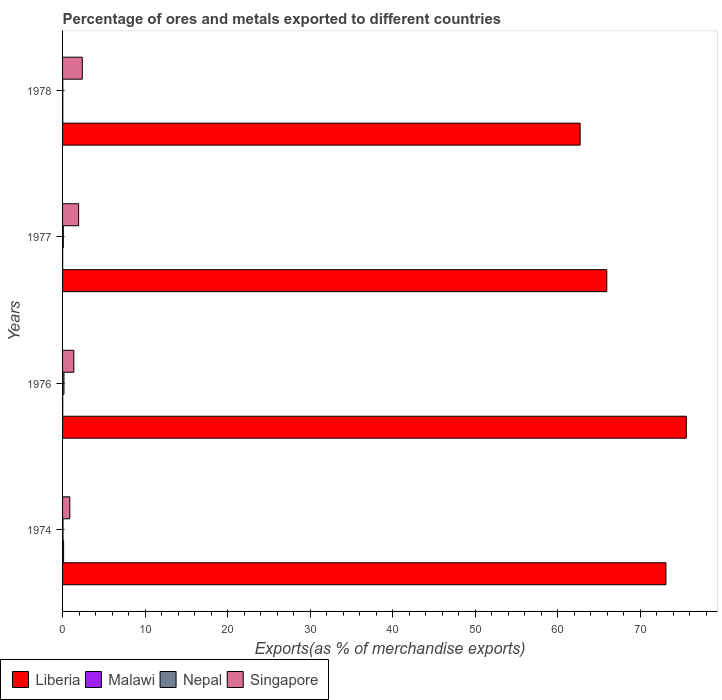How many different coloured bars are there?
Your response must be concise. 4. How many groups of bars are there?
Give a very brief answer. 4. How many bars are there on the 2nd tick from the top?
Make the answer very short. 4. How many bars are there on the 4th tick from the bottom?
Ensure brevity in your answer.  4. What is the label of the 1st group of bars from the top?
Ensure brevity in your answer.  1978. In how many cases, is the number of bars for a given year not equal to the number of legend labels?
Your answer should be very brief. 0. What is the percentage of exports to different countries in Liberia in 1978?
Your answer should be very brief. 62.74. Across all years, what is the maximum percentage of exports to different countries in Malawi?
Make the answer very short. 0.13. Across all years, what is the minimum percentage of exports to different countries in Malawi?
Make the answer very short. 0.01. In which year was the percentage of exports to different countries in Singapore maximum?
Provide a succinct answer. 1978. In which year was the percentage of exports to different countries in Singapore minimum?
Your answer should be compact. 1974. What is the total percentage of exports to different countries in Malawi in the graph?
Ensure brevity in your answer.  0.19. What is the difference between the percentage of exports to different countries in Liberia in 1976 and that in 1978?
Your answer should be compact. 12.87. What is the difference between the percentage of exports to different countries in Nepal in 1976 and the percentage of exports to different countries in Malawi in 1974?
Offer a terse response. 0.04. What is the average percentage of exports to different countries in Singapore per year?
Provide a short and direct response. 1.65. In the year 1976, what is the difference between the percentage of exports to different countries in Liberia and percentage of exports to different countries in Malawi?
Ensure brevity in your answer.  75.59. What is the ratio of the percentage of exports to different countries in Nepal in 1974 to that in 1976?
Ensure brevity in your answer.  0.31. Is the percentage of exports to different countries in Singapore in 1976 less than that in 1978?
Your answer should be compact. Yes. What is the difference between the highest and the second highest percentage of exports to different countries in Malawi?
Offer a terse response. 0.1. What is the difference between the highest and the lowest percentage of exports to different countries in Liberia?
Your answer should be compact. 12.87. Is the sum of the percentage of exports to different countries in Malawi in 1976 and 1978 greater than the maximum percentage of exports to different countries in Singapore across all years?
Keep it short and to the point. No. Is it the case that in every year, the sum of the percentage of exports to different countries in Liberia and percentage of exports to different countries in Malawi is greater than the sum of percentage of exports to different countries in Nepal and percentage of exports to different countries in Singapore?
Provide a succinct answer. Yes. What does the 1st bar from the top in 1974 represents?
Give a very brief answer. Singapore. What does the 3rd bar from the bottom in 1977 represents?
Offer a terse response. Nepal. Is it the case that in every year, the sum of the percentage of exports to different countries in Singapore and percentage of exports to different countries in Nepal is greater than the percentage of exports to different countries in Malawi?
Offer a terse response. Yes. How many bars are there?
Keep it short and to the point. 16. Are all the bars in the graph horizontal?
Make the answer very short. Yes. Are the values on the major ticks of X-axis written in scientific E-notation?
Provide a succinct answer. No. Does the graph contain any zero values?
Make the answer very short. No. Does the graph contain grids?
Offer a very short reply. No. Where does the legend appear in the graph?
Ensure brevity in your answer.  Bottom left. What is the title of the graph?
Ensure brevity in your answer.  Percentage of ores and metals exported to different countries. Does "Heavily indebted poor countries" appear as one of the legend labels in the graph?
Provide a succinct answer. No. What is the label or title of the X-axis?
Give a very brief answer. Exports(as % of merchandise exports). What is the Exports(as % of merchandise exports) of Liberia in 1974?
Provide a short and direct response. 73.15. What is the Exports(as % of merchandise exports) in Malawi in 1974?
Your response must be concise. 0.13. What is the Exports(as % of merchandise exports) of Nepal in 1974?
Offer a very short reply. 0.05. What is the Exports(as % of merchandise exports) in Singapore in 1974?
Offer a terse response. 0.88. What is the Exports(as % of merchandise exports) in Liberia in 1976?
Ensure brevity in your answer.  75.61. What is the Exports(as % of merchandise exports) of Malawi in 1976?
Your response must be concise. 0.02. What is the Exports(as % of merchandise exports) in Nepal in 1976?
Give a very brief answer. 0.17. What is the Exports(as % of merchandise exports) of Singapore in 1976?
Make the answer very short. 1.36. What is the Exports(as % of merchandise exports) of Liberia in 1977?
Provide a succinct answer. 65.97. What is the Exports(as % of merchandise exports) of Malawi in 1977?
Your response must be concise. 0.01. What is the Exports(as % of merchandise exports) of Nepal in 1977?
Your answer should be very brief. 0.09. What is the Exports(as % of merchandise exports) of Singapore in 1977?
Provide a short and direct response. 1.95. What is the Exports(as % of merchandise exports) of Liberia in 1978?
Your response must be concise. 62.74. What is the Exports(as % of merchandise exports) in Malawi in 1978?
Provide a short and direct response. 0.03. What is the Exports(as % of merchandise exports) of Nepal in 1978?
Your response must be concise. 0.03. What is the Exports(as % of merchandise exports) of Singapore in 1978?
Your response must be concise. 2.39. Across all years, what is the maximum Exports(as % of merchandise exports) of Liberia?
Keep it short and to the point. 75.61. Across all years, what is the maximum Exports(as % of merchandise exports) in Malawi?
Give a very brief answer. 0.13. Across all years, what is the maximum Exports(as % of merchandise exports) in Nepal?
Make the answer very short. 0.17. Across all years, what is the maximum Exports(as % of merchandise exports) in Singapore?
Your answer should be very brief. 2.39. Across all years, what is the minimum Exports(as % of merchandise exports) in Liberia?
Provide a succinct answer. 62.74. Across all years, what is the minimum Exports(as % of merchandise exports) of Malawi?
Provide a succinct answer. 0.01. Across all years, what is the minimum Exports(as % of merchandise exports) in Nepal?
Your answer should be very brief. 0.03. Across all years, what is the minimum Exports(as % of merchandise exports) of Singapore?
Your answer should be compact. 0.88. What is the total Exports(as % of merchandise exports) in Liberia in the graph?
Offer a terse response. 277.47. What is the total Exports(as % of merchandise exports) of Malawi in the graph?
Your answer should be compact. 0.19. What is the total Exports(as % of merchandise exports) of Nepal in the graph?
Ensure brevity in your answer.  0.34. What is the total Exports(as % of merchandise exports) in Singapore in the graph?
Keep it short and to the point. 6.58. What is the difference between the Exports(as % of merchandise exports) in Liberia in 1974 and that in 1976?
Make the answer very short. -2.47. What is the difference between the Exports(as % of merchandise exports) in Malawi in 1974 and that in 1976?
Give a very brief answer. 0.11. What is the difference between the Exports(as % of merchandise exports) in Nepal in 1974 and that in 1976?
Offer a very short reply. -0.12. What is the difference between the Exports(as % of merchandise exports) in Singapore in 1974 and that in 1976?
Your answer should be compact. -0.49. What is the difference between the Exports(as % of merchandise exports) in Liberia in 1974 and that in 1977?
Your answer should be very brief. 7.17. What is the difference between the Exports(as % of merchandise exports) of Malawi in 1974 and that in 1977?
Your answer should be very brief. 0.11. What is the difference between the Exports(as % of merchandise exports) of Nepal in 1974 and that in 1977?
Provide a succinct answer. -0.04. What is the difference between the Exports(as % of merchandise exports) of Singapore in 1974 and that in 1977?
Your response must be concise. -1.07. What is the difference between the Exports(as % of merchandise exports) of Liberia in 1974 and that in 1978?
Your response must be concise. 10.41. What is the difference between the Exports(as % of merchandise exports) in Malawi in 1974 and that in 1978?
Provide a short and direct response. 0.1. What is the difference between the Exports(as % of merchandise exports) in Nepal in 1974 and that in 1978?
Give a very brief answer. 0.02. What is the difference between the Exports(as % of merchandise exports) of Singapore in 1974 and that in 1978?
Make the answer very short. -1.51. What is the difference between the Exports(as % of merchandise exports) of Liberia in 1976 and that in 1977?
Provide a short and direct response. 9.64. What is the difference between the Exports(as % of merchandise exports) in Malawi in 1976 and that in 1977?
Give a very brief answer. 0.01. What is the difference between the Exports(as % of merchandise exports) of Nepal in 1976 and that in 1977?
Your answer should be very brief. 0.08. What is the difference between the Exports(as % of merchandise exports) in Singapore in 1976 and that in 1977?
Offer a terse response. -0.58. What is the difference between the Exports(as % of merchandise exports) in Liberia in 1976 and that in 1978?
Provide a succinct answer. 12.87. What is the difference between the Exports(as % of merchandise exports) of Malawi in 1976 and that in 1978?
Offer a terse response. -0.01. What is the difference between the Exports(as % of merchandise exports) in Nepal in 1976 and that in 1978?
Your response must be concise. 0.14. What is the difference between the Exports(as % of merchandise exports) in Singapore in 1976 and that in 1978?
Give a very brief answer. -1.03. What is the difference between the Exports(as % of merchandise exports) in Liberia in 1977 and that in 1978?
Make the answer very short. 3.23. What is the difference between the Exports(as % of merchandise exports) of Malawi in 1977 and that in 1978?
Provide a short and direct response. -0.01. What is the difference between the Exports(as % of merchandise exports) in Nepal in 1977 and that in 1978?
Make the answer very short. 0.06. What is the difference between the Exports(as % of merchandise exports) of Singapore in 1977 and that in 1978?
Your answer should be very brief. -0.45. What is the difference between the Exports(as % of merchandise exports) of Liberia in 1974 and the Exports(as % of merchandise exports) of Malawi in 1976?
Keep it short and to the point. 73.13. What is the difference between the Exports(as % of merchandise exports) in Liberia in 1974 and the Exports(as % of merchandise exports) in Nepal in 1976?
Give a very brief answer. 72.98. What is the difference between the Exports(as % of merchandise exports) in Liberia in 1974 and the Exports(as % of merchandise exports) in Singapore in 1976?
Make the answer very short. 71.78. What is the difference between the Exports(as % of merchandise exports) of Malawi in 1974 and the Exports(as % of merchandise exports) of Nepal in 1976?
Keep it short and to the point. -0.04. What is the difference between the Exports(as % of merchandise exports) of Malawi in 1974 and the Exports(as % of merchandise exports) of Singapore in 1976?
Keep it short and to the point. -1.24. What is the difference between the Exports(as % of merchandise exports) in Nepal in 1974 and the Exports(as % of merchandise exports) in Singapore in 1976?
Make the answer very short. -1.31. What is the difference between the Exports(as % of merchandise exports) of Liberia in 1974 and the Exports(as % of merchandise exports) of Malawi in 1977?
Keep it short and to the point. 73.13. What is the difference between the Exports(as % of merchandise exports) of Liberia in 1974 and the Exports(as % of merchandise exports) of Nepal in 1977?
Your answer should be very brief. 73.06. What is the difference between the Exports(as % of merchandise exports) of Liberia in 1974 and the Exports(as % of merchandise exports) of Singapore in 1977?
Provide a succinct answer. 71.2. What is the difference between the Exports(as % of merchandise exports) of Malawi in 1974 and the Exports(as % of merchandise exports) of Nepal in 1977?
Your answer should be very brief. 0.04. What is the difference between the Exports(as % of merchandise exports) in Malawi in 1974 and the Exports(as % of merchandise exports) in Singapore in 1977?
Ensure brevity in your answer.  -1.82. What is the difference between the Exports(as % of merchandise exports) in Nepal in 1974 and the Exports(as % of merchandise exports) in Singapore in 1977?
Give a very brief answer. -1.89. What is the difference between the Exports(as % of merchandise exports) in Liberia in 1974 and the Exports(as % of merchandise exports) in Malawi in 1978?
Give a very brief answer. 73.12. What is the difference between the Exports(as % of merchandise exports) in Liberia in 1974 and the Exports(as % of merchandise exports) in Nepal in 1978?
Give a very brief answer. 73.12. What is the difference between the Exports(as % of merchandise exports) in Liberia in 1974 and the Exports(as % of merchandise exports) in Singapore in 1978?
Offer a very short reply. 70.75. What is the difference between the Exports(as % of merchandise exports) of Malawi in 1974 and the Exports(as % of merchandise exports) of Nepal in 1978?
Keep it short and to the point. 0.1. What is the difference between the Exports(as % of merchandise exports) of Malawi in 1974 and the Exports(as % of merchandise exports) of Singapore in 1978?
Provide a short and direct response. -2.27. What is the difference between the Exports(as % of merchandise exports) of Nepal in 1974 and the Exports(as % of merchandise exports) of Singapore in 1978?
Your answer should be compact. -2.34. What is the difference between the Exports(as % of merchandise exports) in Liberia in 1976 and the Exports(as % of merchandise exports) in Malawi in 1977?
Your answer should be very brief. 75.6. What is the difference between the Exports(as % of merchandise exports) in Liberia in 1976 and the Exports(as % of merchandise exports) in Nepal in 1977?
Offer a terse response. 75.52. What is the difference between the Exports(as % of merchandise exports) in Liberia in 1976 and the Exports(as % of merchandise exports) in Singapore in 1977?
Keep it short and to the point. 73.67. What is the difference between the Exports(as % of merchandise exports) of Malawi in 1976 and the Exports(as % of merchandise exports) of Nepal in 1977?
Your response must be concise. -0.07. What is the difference between the Exports(as % of merchandise exports) of Malawi in 1976 and the Exports(as % of merchandise exports) of Singapore in 1977?
Offer a very short reply. -1.92. What is the difference between the Exports(as % of merchandise exports) in Nepal in 1976 and the Exports(as % of merchandise exports) in Singapore in 1977?
Provide a short and direct response. -1.78. What is the difference between the Exports(as % of merchandise exports) in Liberia in 1976 and the Exports(as % of merchandise exports) in Malawi in 1978?
Provide a succinct answer. 75.58. What is the difference between the Exports(as % of merchandise exports) of Liberia in 1976 and the Exports(as % of merchandise exports) of Nepal in 1978?
Provide a short and direct response. 75.58. What is the difference between the Exports(as % of merchandise exports) in Liberia in 1976 and the Exports(as % of merchandise exports) in Singapore in 1978?
Your answer should be very brief. 73.22. What is the difference between the Exports(as % of merchandise exports) in Malawi in 1976 and the Exports(as % of merchandise exports) in Nepal in 1978?
Your answer should be compact. -0.01. What is the difference between the Exports(as % of merchandise exports) in Malawi in 1976 and the Exports(as % of merchandise exports) in Singapore in 1978?
Keep it short and to the point. -2.37. What is the difference between the Exports(as % of merchandise exports) in Nepal in 1976 and the Exports(as % of merchandise exports) in Singapore in 1978?
Keep it short and to the point. -2.22. What is the difference between the Exports(as % of merchandise exports) in Liberia in 1977 and the Exports(as % of merchandise exports) in Malawi in 1978?
Keep it short and to the point. 65.95. What is the difference between the Exports(as % of merchandise exports) of Liberia in 1977 and the Exports(as % of merchandise exports) of Nepal in 1978?
Your response must be concise. 65.95. What is the difference between the Exports(as % of merchandise exports) in Liberia in 1977 and the Exports(as % of merchandise exports) in Singapore in 1978?
Provide a succinct answer. 63.58. What is the difference between the Exports(as % of merchandise exports) of Malawi in 1977 and the Exports(as % of merchandise exports) of Nepal in 1978?
Provide a succinct answer. -0.02. What is the difference between the Exports(as % of merchandise exports) of Malawi in 1977 and the Exports(as % of merchandise exports) of Singapore in 1978?
Keep it short and to the point. -2.38. What is the difference between the Exports(as % of merchandise exports) of Nepal in 1977 and the Exports(as % of merchandise exports) of Singapore in 1978?
Give a very brief answer. -2.3. What is the average Exports(as % of merchandise exports) of Liberia per year?
Give a very brief answer. 69.37. What is the average Exports(as % of merchandise exports) in Malawi per year?
Offer a very short reply. 0.05. What is the average Exports(as % of merchandise exports) in Nepal per year?
Offer a terse response. 0.08. What is the average Exports(as % of merchandise exports) in Singapore per year?
Offer a terse response. 1.65. In the year 1974, what is the difference between the Exports(as % of merchandise exports) of Liberia and Exports(as % of merchandise exports) of Malawi?
Offer a very short reply. 73.02. In the year 1974, what is the difference between the Exports(as % of merchandise exports) in Liberia and Exports(as % of merchandise exports) in Nepal?
Give a very brief answer. 73.09. In the year 1974, what is the difference between the Exports(as % of merchandise exports) of Liberia and Exports(as % of merchandise exports) of Singapore?
Offer a very short reply. 72.27. In the year 1974, what is the difference between the Exports(as % of merchandise exports) in Malawi and Exports(as % of merchandise exports) in Nepal?
Offer a very short reply. 0.07. In the year 1974, what is the difference between the Exports(as % of merchandise exports) of Malawi and Exports(as % of merchandise exports) of Singapore?
Your answer should be compact. -0.75. In the year 1974, what is the difference between the Exports(as % of merchandise exports) of Nepal and Exports(as % of merchandise exports) of Singapore?
Ensure brevity in your answer.  -0.83. In the year 1976, what is the difference between the Exports(as % of merchandise exports) of Liberia and Exports(as % of merchandise exports) of Malawi?
Make the answer very short. 75.59. In the year 1976, what is the difference between the Exports(as % of merchandise exports) of Liberia and Exports(as % of merchandise exports) of Nepal?
Make the answer very short. 75.44. In the year 1976, what is the difference between the Exports(as % of merchandise exports) in Liberia and Exports(as % of merchandise exports) in Singapore?
Provide a short and direct response. 74.25. In the year 1976, what is the difference between the Exports(as % of merchandise exports) in Malawi and Exports(as % of merchandise exports) in Nepal?
Your response must be concise. -0.15. In the year 1976, what is the difference between the Exports(as % of merchandise exports) of Malawi and Exports(as % of merchandise exports) of Singapore?
Your response must be concise. -1.34. In the year 1976, what is the difference between the Exports(as % of merchandise exports) in Nepal and Exports(as % of merchandise exports) in Singapore?
Keep it short and to the point. -1.2. In the year 1977, what is the difference between the Exports(as % of merchandise exports) in Liberia and Exports(as % of merchandise exports) in Malawi?
Your response must be concise. 65.96. In the year 1977, what is the difference between the Exports(as % of merchandise exports) of Liberia and Exports(as % of merchandise exports) of Nepal?
Provide a short and direct response. 65.88. In the year 1977, what is the difference between the Exports(as % of merchandise exports) in Liberia and Exports(as % of merchandise exports) in Singapore?
Your answer should be compact. 64.03. In the year 1977, what is the difference between the Exports(as % of merchandise exports) in Malawi and Exports(as % of merchandise exports) in Nepal?
Provide a succinct answer. -0.08. In the year 1977, what is the difference between the Exports(as % of merchandise exports) of Malawi and Exports(as % of merchandise exports) of Singapore?
Keep it short and to the point. -1.93. In the year 1977, what is the difference between the Exports(as % of merchandise exports) in Nepal and Exports(as % of merchandise exports) in Singapore?
Give a very brief answer. -1.86. In the year 1978, what is the difference between the Exports(as % of merchandise exports) in Liberia and Exports(as % of merchandise exports) in Malawi?
Your answer should be very brief. 62.71. In the year 1978, what is the difference between the Exports(as % of merchandise exports) of Liberia and Exports(as % of merchandise exports) of Nepal?
Keep it short and to the point. 62.71. In the year 1978, what is the difference between the Exports(as % of merchandise exports) in Liberia and Exports(as % of merchandise exports) in Singapore?
Offer a terse response. 60.35. In the year 1978, what is the difference between the Exports(as % of merchandise exports) of Malawi and Exports(as % of merchandise exports) of Nepal?
Offer a terse response. -0. In the year 1978, what is the difference between the Exports(as % of merchandise exports) in Malawi and Exports(as % of merchandise exports) in Singapore?
Provide a succinct answer. -2.37. In the year 1978, what is the difference between the Exports(as % of merchandise exports) in Nepal and Exports(as % of merchandise exports) in Singapore?
Keep it short and to the point. -2.37. What is the ratio of the Exports(as % of merchandise exports) in Liberia in 1974 to that in 1976?
Your answer should be compact. 0.97. What is the ratio of the Exports(as % of merchandise exports) of Malawi in 1974 to that in 1976?
Provide a succinct answer. 6.03. What is the ratio of the Exports(as % of merchandise exports) of Nepal in 1974 to that in 1976?
Your answer should be compact. 0.31. What is the ratio of the Exports(as % of merchandise exports) in Singapore in 1974 to that in 1976?
Keep it short and to the point. 0.64. What is the ratio of the Exports(as % of merchandise exports) of Liberia in 1974 to that in 1977?
Offer a terse response. 1.11. What is the ratio of the Exports(as % of merchandise exports) of Malawi in 1974 to that in 1977?
Your answer should be very brief. 10.3. What is the ratio of the Exports(as % of merchandise exports) in Nepal in 1974 to that in 1977?
Offer a very short reply. 0.57. What is the ratio of the Exports(as % of merchandise exports) of Singapore in 1974 to that in 1977?
Keep it short and to the point. 0.45. What is the ratio of the Exports(as % of merchandise exports) of Liberia in 1974 to that in 1978?
Your answer should be very brief. 1.17. What is the ratio of the Exports(as % of merchandise exports) in Malawi in 1974 to that in 1978?
Offer a terse response. 4.73. What is the ratio of the Exports(as % of merchandise exports) of Nepal in 1974 to that in 1978?
Provide a succinct answer. 1.88. What is the ratio of the Exports(as % of merchandise exports) of Singapore in 1974 to that in 1978?
Offer a terse response. 0.37. What is the ratio of the Exports(as % of merchandise exports) of Liberia in 1976 to that in 1977?
Give a very brief answer. 1.15. What is the ratio of the Exports(as % of merchandise exports) of Malawi in 1976 to that in 1977?
Provide a succinct answer. 1.71. What is the ratio of the Exports(as % of merchandise exports) in Nepal in 1976 to that in 1977?
Your answer should be compact. 1.86. What is the ratio of the Exports(as % of merchandise exports) of Singapore in 1976 to that in 1977?
Keep it short and to the point. 0.7. What is the ratio of the Exports(as % of merchandise exports) of Liberia in 1976 to that in 1978?
Keep it short and to the point. 1.21. What is the ratio of the Exports(as % of merchandise exports) in Malawi in 1976 to that in 1978?
Provide a short and direct response. 0.79. What is the ratio of the Exports(as % of merchandise exports) of Nepal in 1976 to that in 1978?
Your answer should be compact. 6.11. What is the ratio of the Exports(as % of merchandise exports) of Singapore in 1976 to that in 1978?
Make the answer very short. 0.57. What is the ratio of the Exports(as % of merchandise exports) in Liberia in 1977 to that in 1978?
Offer a terse response. 1.05. What is the ratio of the Exports(as % of merchandise exports) of Malawi in 1977 to that in 1978?
Make the answer very short. 0.46. What is the ratio of the Exports(as % of merchandise exports) of Nepal in 1977 to that in 1978?
Provide a short and direct response. 3.28. What is the ratio of the Exports(as % of merchandise exports) in Singapore in 1977 to that in 1978?
Your response must be concise. 0.81. What is the difference between the highest and the second highest Exports(as % of merchandise exports) in Liberia?
Keep it short and to the point. 2.47. What is the difference between the highest and the second highest Exports(as % of merchandise exports) of Malawi?
Provide a short and direct response. 0.1. What is the difference between the highest and the second highest Exports(as % of merchandise exports) of Nepal?
Ensure brevity in your answer.  0.08. What is the difference between the highest and the second highest Exports(as % of merchandise exports) of Singapore?
Keep it short and to the point. 0.45. What is the difference between the highest and the lowest Exports(as % of merchandise exports) of Liberia?
Your response must be concise. 12.87. What is the difference between the highest and the lowest Exports(as % of merchandise exports) of Malawi?
Your answer should be very brief. 0.11. What is the difference between the highest and the lowest Exports(as % of merchandise exports) of Nepal?
Ensure brevity in your answer.  0.14. What is the difference between the highest and the lowest Exports(as % of merchandise exports) of Singapore?
Provide a succinct answer. 1.51. 